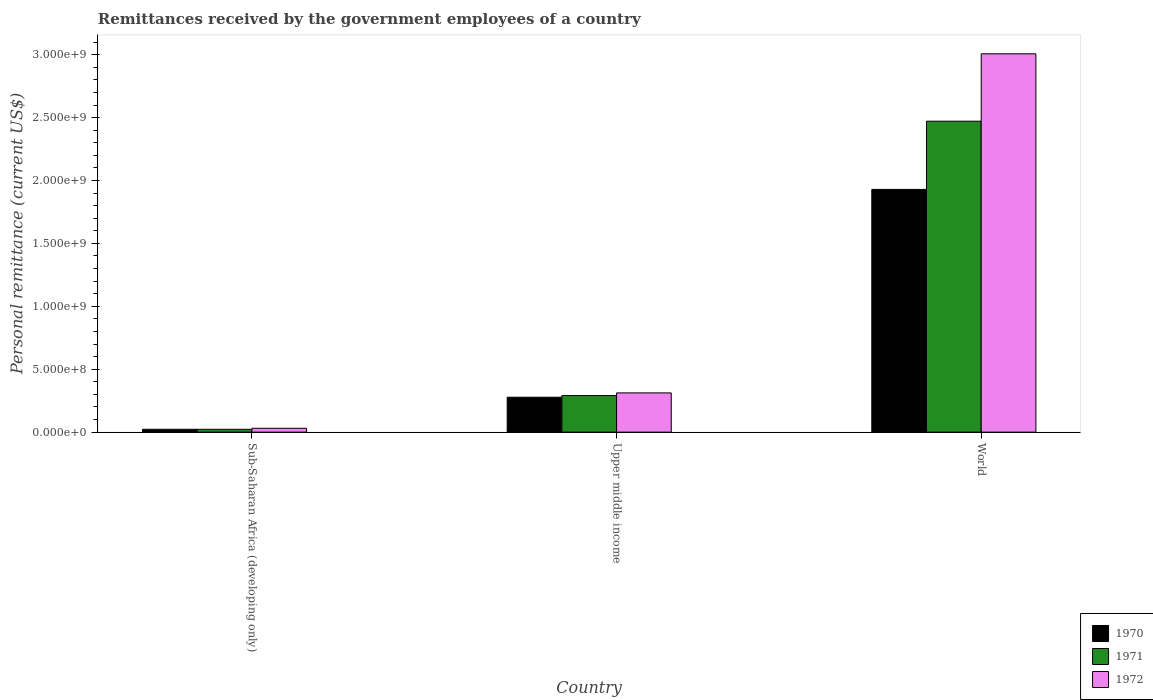How many different coloured bars are there?
Your answer should be very brief. 3. How many groups of bars are there?
Keep it short and to the point. 3. Are the number of bars on each tick of the X-axis equal?
Your answer should be very brief. Yes. How many bars are there on the 3rd tick from the right?
Ensure brevity in your answer.  3. What is the label of the 3rd group of bars from the left?
Provide a short and direct response. World. In how many cases, is the number of bars for a given country not equal to the number of legend labels?
Keep it short and to the point. 0. What is the remittances received by the government employees in 1971 in Upper middle income?
Ensure brevity in your answer.  2.91e+08. Across all countries, what is the maximum remittances received by the government employees in 1971?
Provide a short and direct response. 2.47e+09. Across all countries, what is the minimum remittances received by the government employees in 1971?
Your response must be concise. 2.26e+07. In which country was the remittances received by the government employees in 1972 maximum?
Your answer should be compact. World. In which country was the remittances received by the government employees in 1972 minimum?
Ensure brevity in your answer.  Sub-Saharan Africa (developing only). What is the total remittances received by the government employees in 1970 in the graph?
Your answer should be very brief. 2.23e+09. What is the difference between the remittances received by the government employees in 1970 in Sub-Saharan Africa (developing only) and that in World?
Provide a succinct answer. -1.91e+09. What is the difference between the remittances received by the government employees in 1970 in World and the remittances received by the government employees in 1972 in Sub-Saharan Africa (developing only)?
Provide a short and direct response. 1.90e+09. What is the average remittances received by the government employees in 1971 per country?
Provide a succinct answer. 9.28e+08. What is the difference between the remittances received by the government employees of/in 1972 and remittances received by the government employees of/in 1970 in Sub-Saharan Africa (developing only)?
Provide a succinct answer. 8.07e+06. In how many countries, is the remittances received by the government employees in 1970 greater than 300000000 US$?
Offer a terse response. 1. What is the ratio of the remittances received by the government employees in 1971 in Upper middle income to that in World?
Your response must be concise. 0.12. Is the remittances received by the government employees in 1971 in Sub-Saharan Africa (developing only) less than that in Upper middle income?
Offer a terse response. Yes. Is the difference between the remittances received by the government employees in 1972 in Sub-Saharan Africa (developing only) and Upper middle income greater than the difference between the remittances received by the government employees in 1970 in Sub-Saharan Africa (developing only) and Upper middle income?
Make the answer very short. No. What is the difference between the highest and the second highest remittances received by the government employees in 1972?
Give a very brief answer. 2.98e+09. What is the difference between the highest and the lowest remittances received by the government employees in 1972?
Give a very brief answer. 2.98e+09. In how many countries, is the remittances received by the government employees in 1971 greater than the average remittances received by the government employees in 1971 taken over all countries?
Your answer should be very brief. 1. Is the sum of the remittances received by the government employees in 1972 in Sub-Saharan Africa (developing only) and World greater than the maximum remittances received by the government employees in 1971 across all countries?
Offer a terse response. Yes. What does the 1st bar from the right in Upper middle income represents?
Ensure brevity in your answer.  1972. How many countries are there in the graph?
Make the answer very short. 3. What is the difference between two consecutive major ticks on the Y-axis?
Offer a terse response. 5.00e+08. Are the values on the major ticks of Y-axis written in scientific E-notation?
Your answer should be compact. Yes. What is the title of the graph?
Make the answer very short. Remittances received by the government employees of a country. Does "1992" appear as one of the legend labels in the graph?
Offer a very short reply. No. What is the label or title of the X-axis?
Make the answer very short. Country. What is the label or title of the Y-axis?
Your answer should be compact. Personal remittance (current US$). What is the Personal remittance (current US$) in 1970 in Sub-Saharan Africa (developing only)?
Your response must be concise. 2.27e+07. What is the Personal remittance (current US$) of 1971 in Sub-Saharan Africa (developing only)?
Ensure brevity in your answer.  2.26e+07. What is the Personal remittance (current US$) of 1972 in Sub-Saharan Africa (developing only)?
Keep it short and to the point. 3.07e+07. What is the Personal remittance (current US$) in 1970 in Upper middle income?
Offer a terse response. 2.77e+08. What is the Personal remittance (current US$) in 1971 in Upper middle income?
Ensure brevity in your answer.  2.91e+08. What is the Personal remittance (current US$) in 1972 in Upper middle income?
Your answer should be very brief. 3.12e+08. What is the Personal remittance (current US$) in 1970 in World?
Offer a very short reply. 1.93e+09. What is the Personal remittance (current US$) in 1971 in World?
Offer a very short reply. 2.47e+09. What is the Personal remittance (current US$) of 1972 in World?
Give a very brief answer. 3.01e+09. Across all countries, what is the maximum Personal remittance (current US$) in 1970?
Your answer should be compact. 1.93e+09. Across all countries, what is the maximum Personal remittance (current US$) of 1971?
Ensure brevity in your answer.  2.47e+09. Across all countries, what is the maximum Personal remittance (current US$) of 1972?
Give a very brief answer. 3.01e+09. Across all countries, what is the minimum Personal remittance (current US$) in 1970?
Offer a very short reply. 2.27e+07. Across all countries, what is the minimum Personal remittance (current US$) in 1971?
Provide a short and direct response. 2.26e+07. Across all countries, what is the minimum Personal remittance (current US$) in 1972?
Make the answer very short. 3.07e+07. What is the total Personal remittance (current US$) of 1970 in the graph?
Your answer should be compact. 2.23e+09. What is the total Personal remittance (current US$) in 1971 in the graph?
Offer a terse response. 2.78e+09. What is the total Personal remittance (current US$) of 1972 in the graph?
Provide a succinct answer. 3.35e+09. What is the difference between the Personal remittance (current US$) of 1970 in Sub-Saharan Africa (developing only) and that in Upper middle income?
Your answer should be very brief. -2.55e+08. What is the difference between the Personal remittance (current US$) in 1971 in Sub-Saharan Africa (developing only) and that in Upper middle income?
Your answer should be very brief. -2.68e+08. What is the difference between the Personal remittance (current US$) of 1972 in Sub-Saharan Africa (developing only) and that in Upper middle income?
Your response must be concise. -2.81e+08. What is the difference between the Personal remittance (current US$) in 1970 in Sub-Saharan Africa (developing only) and that in World?
Your response must be concise. -1.91e+09. What is the difference between the Personal remittance (current US$) in 1971 in Sub-Saharan Africa (developing only) and that in World?
Make the answer very short. -2.45e+09. What is the difference between the Personal remittance (current US$) in 1972 in Sub-Saharan Africa (developing only) and that in World?
Offer a terse response. -2.98e+09. What is the difference between the Personal remittance (current US$) in 1970 in Upper middle income and that in World?
Keep it short and to the point. -1.65e+09. What is the difference between the Personal remittance (current US$) in 1971 in Upper middle income and that in World?
Ensure brevity in your answer.  -2.18e+09. What is the difference between the Personal remittance (current US$) of 1972 in Upper middle income and that in World?
Offer a terse response. -2.70e+09. What is the difference between the Personal remittance (current US$) of 1970 in Sub-Saharan Africa (developing only) and the Personal remittance (current US$) of 1971 in Upper middle income?
Provide a succinct answer. -2.68e+08. What is the difference between the Personal remittance (current US$) in 1970 in Sub-Saharan Africa (developing only) and the Personal remittance (current US$) in 1972 in Upper middle income?
Provide a short and direct response. -2.89e+08. What is the difference between the Personal remittance (current US$) in 1971 in Sub-Saharan Africa (developing only) and the Personal remittance (current US$) in 1972 in Upper middle income?
Provide a short and direct response. -2.89e+08. What is the difference between the Personal remittance (current US$) of 1970 in Sub-Saharan Africa (developing only) and the Personal remittance (current US$) of 1971 in World?
Give a very brief answer. -2.45e+09. What is the difference between the Personal remittance (current US$) of 1970 in Sub-Saharan Africa (developing only) and the Personal remittance (current US$) of 1972 in World?
Your response must be concise. -2.98e+09. What is the difference between the Personal remittance (current US$) of 1971 in Sub-Saharan Africa (developing only) and the Personal remittance (current US$) of 1972 in World?
Offer a terse response. -2.98e+09. What is the difference between the Personal remittance (current US$) in 1970 in Upper middle income and the Personal remittance (current US$) in 1971 in World?
Keep it short and to the point. -2.19e+09. What is the difference between the Personal remittance (current US$) of 1970 in Upper middle income and the Personal remittance (current US$) of 1972 in World?
Provide a short and direct response. -2.73e+09. What is the difference between the Personal remittance (current US$) in 1971 in Upper middle income and the Personal remittance (current US$) in 1972 in World?
Keep it short and to the point. -2.72e+09. What is the average Personal remittance (current US$) in 1970 per country?
Provide a succinct answer. 7.43e+08. What is the average Personal remittance (current US$) in 1971 per country?
Your answer should be compact. 9.28e+08. What is the average Personal remittance (current US$) of 1972 per country?
Make the answer very short. 1.12e+09. What is the difference between the Personal remittance (current US$) of 1970 and Personal remittance (current US$) of 1971 in Sub-Saharan Africa (developing only)?
Provide a short and direct response. 2.18e+04. What is the difference between the Personal remittance (current US$) of 1970 and Personal remittance (current US$) of 1972 in Sub-Saharan Africa (developing only)?
Offer a terse response. -8.07e+06. What is the difference between the Personal remittance (current US$) in 1971 and Personal remittance (current US$) in 1972 in Sub-Saharan Africa (developing only)?
Keep it short and to the point. -8.09e+06. What is the difference between the Personal remittance (current US$) of 1970 and Personal remittance (current US$) of 1971 in Upper middle income?
Make the answer very short. -1.32e+07. What is the difference between the Personal remittance (current US$) in 1970 and Personal remittance (current US$) in 1972 in Upper middle income?
Give a very brief answer. -3.45e+07. What is the difference between the Personal remittance (current US$) of 1971 and Personal remittance (current US$) of 1972 in Upper middle income?
Offer a very short reply. -2.13e+07. What is the difference between the Personal remittance (current US$) of 1970 and Personal remittance (current US$) of 1971 in World?
Offer a very short reply. -5.42e+08. What is the difference between the Personal remittance (current US$) in 1970 and Personal remittance (current US$) in 1972 in World?
Provide a succinct answer. -1.08e+09. What is the difference between the Personal remittance (current US$) of 1971 and Personal remittance (current US$) of 1972 in World?
Ensure brevity in your answer.  -5.36e+08. What is the ratio of the Personal remittance (current US$) of 1970 in Sub-Saharan Africa (developing only) to that in Upper middle income?
Keep it short and to the point. 0.08. What is the ratio of the Personal remittance (current US$) in 1971 in Sub-Saharan Africa (developing only) to that in Upper middle income?
Your answer should be compact. 0.08. What is the ratio of the Personal remittance (current US$) of 1972 in Sub-Saharan Africa (developing only) to that in Upper middle income?
Keep it short and to the point. 0.1. What is the ratio of the Personal remittance (current US$) of 1970 in Sub-Saharan Africa (developing only) to that in World?
Keep it short and to the point. 0.01. What is the ratio of the Personal remittance (current US$) of 1971 in Sub-Saharan Africa (developing only) to that in World?
Keep it short and to the point. 0.01. What is the ratio of the Personal remittance (current US$) of 1972 in Sub-Saharan Africa (developing only) to that in World?
Provide a short and direct response. 0.01. What is the ratio of the Personal remittance (current US$) in 1970 in Upper middle income to that in World?
Give a very brief answer. 0.14. What is the ratio of the Personal remittance (current US$) of 1971 in Upper middle income to that in World?
Your response must be concise. 0.12. What is the ratio of the Personal remittance (current US$) in 1972 in Upper middle income to that in World?
Offer a terse response. 0.1. What is the difference between the highest and the second highest Personal remittance (current US$) of 1970?
Your answer should be compact. 1.65e+09. What is the difference between the highest and the second highest Personal remittance (current US$) of 1971?
Make the answer very short. 2.18e+09. What is the difference between the highest and the second highest Personal remittance (current US$) of 1972?
Your answer should be compact. 2.70e+09. What is the difference between the highest and the lowest Personal remittance (current US$) in 1970?
Offer a very short reply. 1.91e+09. What is the difference between the highest and the lowest Personal remittance (current US$) in 1971?
Provide a succinct answer. 2.45e+09. What is the difference between the highest and the lowest Personal remittance (current US$) of 1972?
Ensure brevity in your answer.  2.98e+09. 